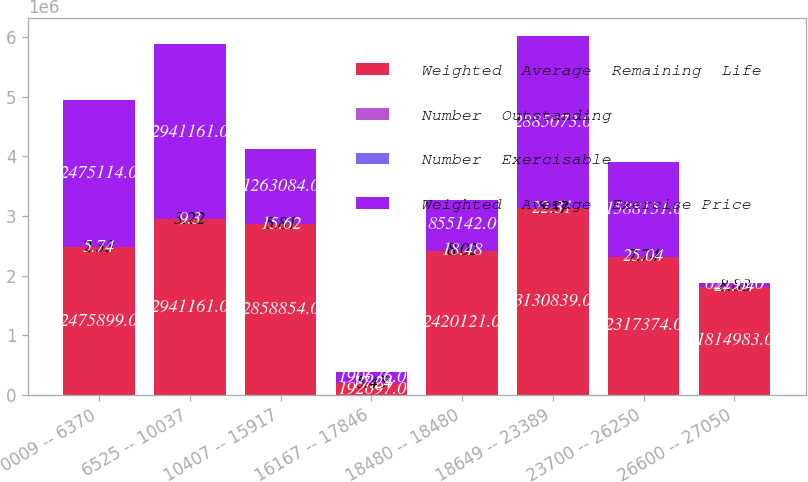<chart> <loc_0><loc_0><loc_500><loc_500><stacked_bar_chart><ecel><fcel>0009 -- 6370<fcel>6525 -- 10037<fcel>10407 -- 15917<fcel>16167 -- 17846<fcel>18480 -- 18480<fcel>18649 -- 23389<fcel>23700 -- 26250<fcel>26600 -- 27050<nl><fcel>Weighted  Average  Remaining  Life<fcel>2.4759e+06<fcel>2.94116e+06<fcel>2.85885e+06<fcel>192097<fcel>2.42012e+06<fcel>3.13084e+06<fcel>2.31737e+06<fcel>1.81498e+06<nl><fcel>Number  Outstanding<fcel>2.33<fcel>3.22<fcel>5.81<fcel>5.45<fcel>8.02<fcel>5.57<fcel>7.74<fcel>8.88<nl><fcel>Number  Exercisable<fcel>5.74<fcel>9.3<fcel>15.62<fcel>17.24<fcel>18.48<fcel>22.31<fcel>25.04<fcel>27.04<nl><fcel>Weighted  Average  Exercise Price<fcel>2.47511e+06<fcel>2.94116e+06<fcel>1.26308e+06<fcel>190676<fcel>855142<fcel>2.88507e+06<fcel>1.58815e+06<fcel>62295<nl></chart> 